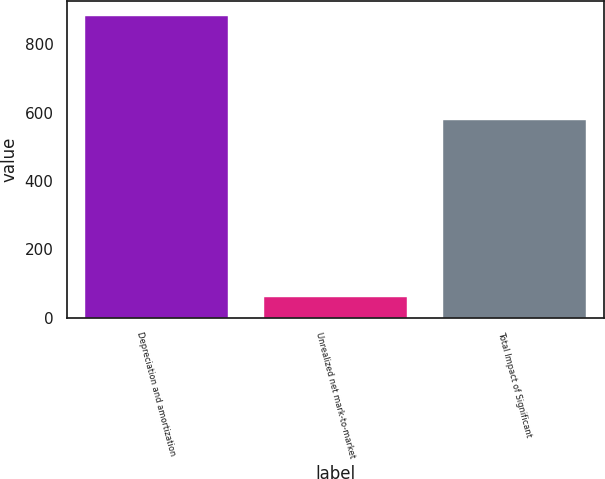Convert chart. <chart><loc_0><loc_0><loc_500><loc_500><bar_chart><fcel>Depreciation and amortization<fcel>Unrealized net mark-to-market<fcel>Total Impact of Significant<nl><fcel>883<fcel>61<fcel>578<nl></chart> 